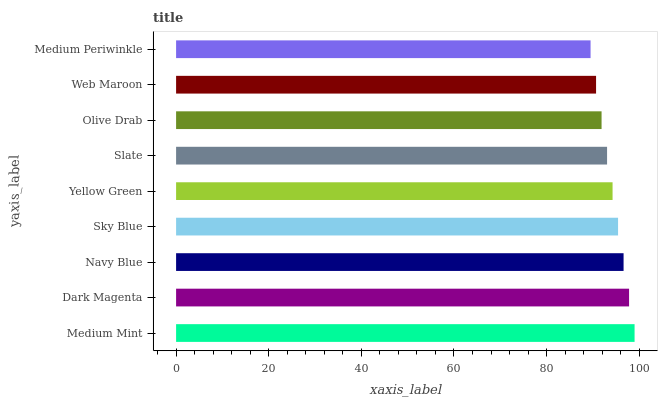Is Medium Periwinkle the minimum?
Answer yes or no. Yes. Is Medium Mint the maximum?
Answer yes or no. Yes. Is Dark Magenta the minimum?
Answer yes or no. No. Is Dark Magenta the maximum?
Answer yes or no. No. Is Medium Mint greater than Dark Magenta?
Answer yes or no. Yes. Is Dark Magenta less than Medium Mint?
Answer yes or no. Yes. Is Dark Magenta greater than Medium Mint?
Answer yes or no. No. Is Medium Mint less than Dark Magenta?
Answer yes or no. No. Is Yellow Green the high median?
Answer yes or no. Yes. Is Yellow Green the low median?
Answer yes or no. Yes. Is Navy Blue the high median?
Answer yes or no. No. Is Medium Periwinkle the low median?
Answer yes or no. No. 